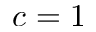<formula> <loc_0><loc_0><loc_500><loc_500>c = 1</formula> 